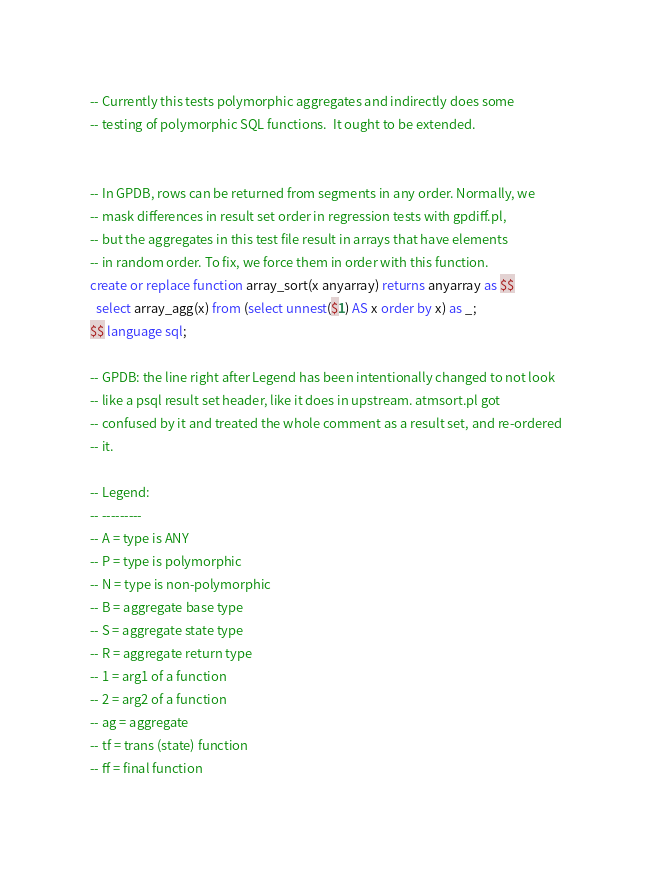<code> <loc_0><loc_0><loc_500><loc_500><_SQL_>-- Currently this tests polymorphic aggregates and indirectly does some
-- testing of polymorphic SQL functions.  It ought to be extended.


-- In GPDB, rows can be returned from segments in any order. Normally, we
-- mask differences in result set order in regression tests with gpdiff.pl,
-- but the aggregates in this test file result in arrays that have elements
-- in random order. To fix, we force them in order with this function.
create or replace function array_sort(x anyarray) returns anyarray as $$
  select array_agg(x) from (select unnest($1) AS x order by x) as _;
$$ language sql;

-- GPDB: the line right after Legend has been intentionally changed to not look
-- like a psql result set header, like it does in upstream. atmsort.pl got
-- confused by it and treated the whole comment as a result set, and re-ordered
-- it.

-- Legend:
-- ---------
-- A = type is ANY
-- P = type is polymorphic
-- N = type is non-polymorphic
-- B = aggregate base type
-- S = aggregate state type
-- R = aggregate return type
-- 1 = arg1 of a function
-- 2 = arg2 of a function
-- ag = aggregate
-- tf = trans (state) function
-- ff = final function</code> 